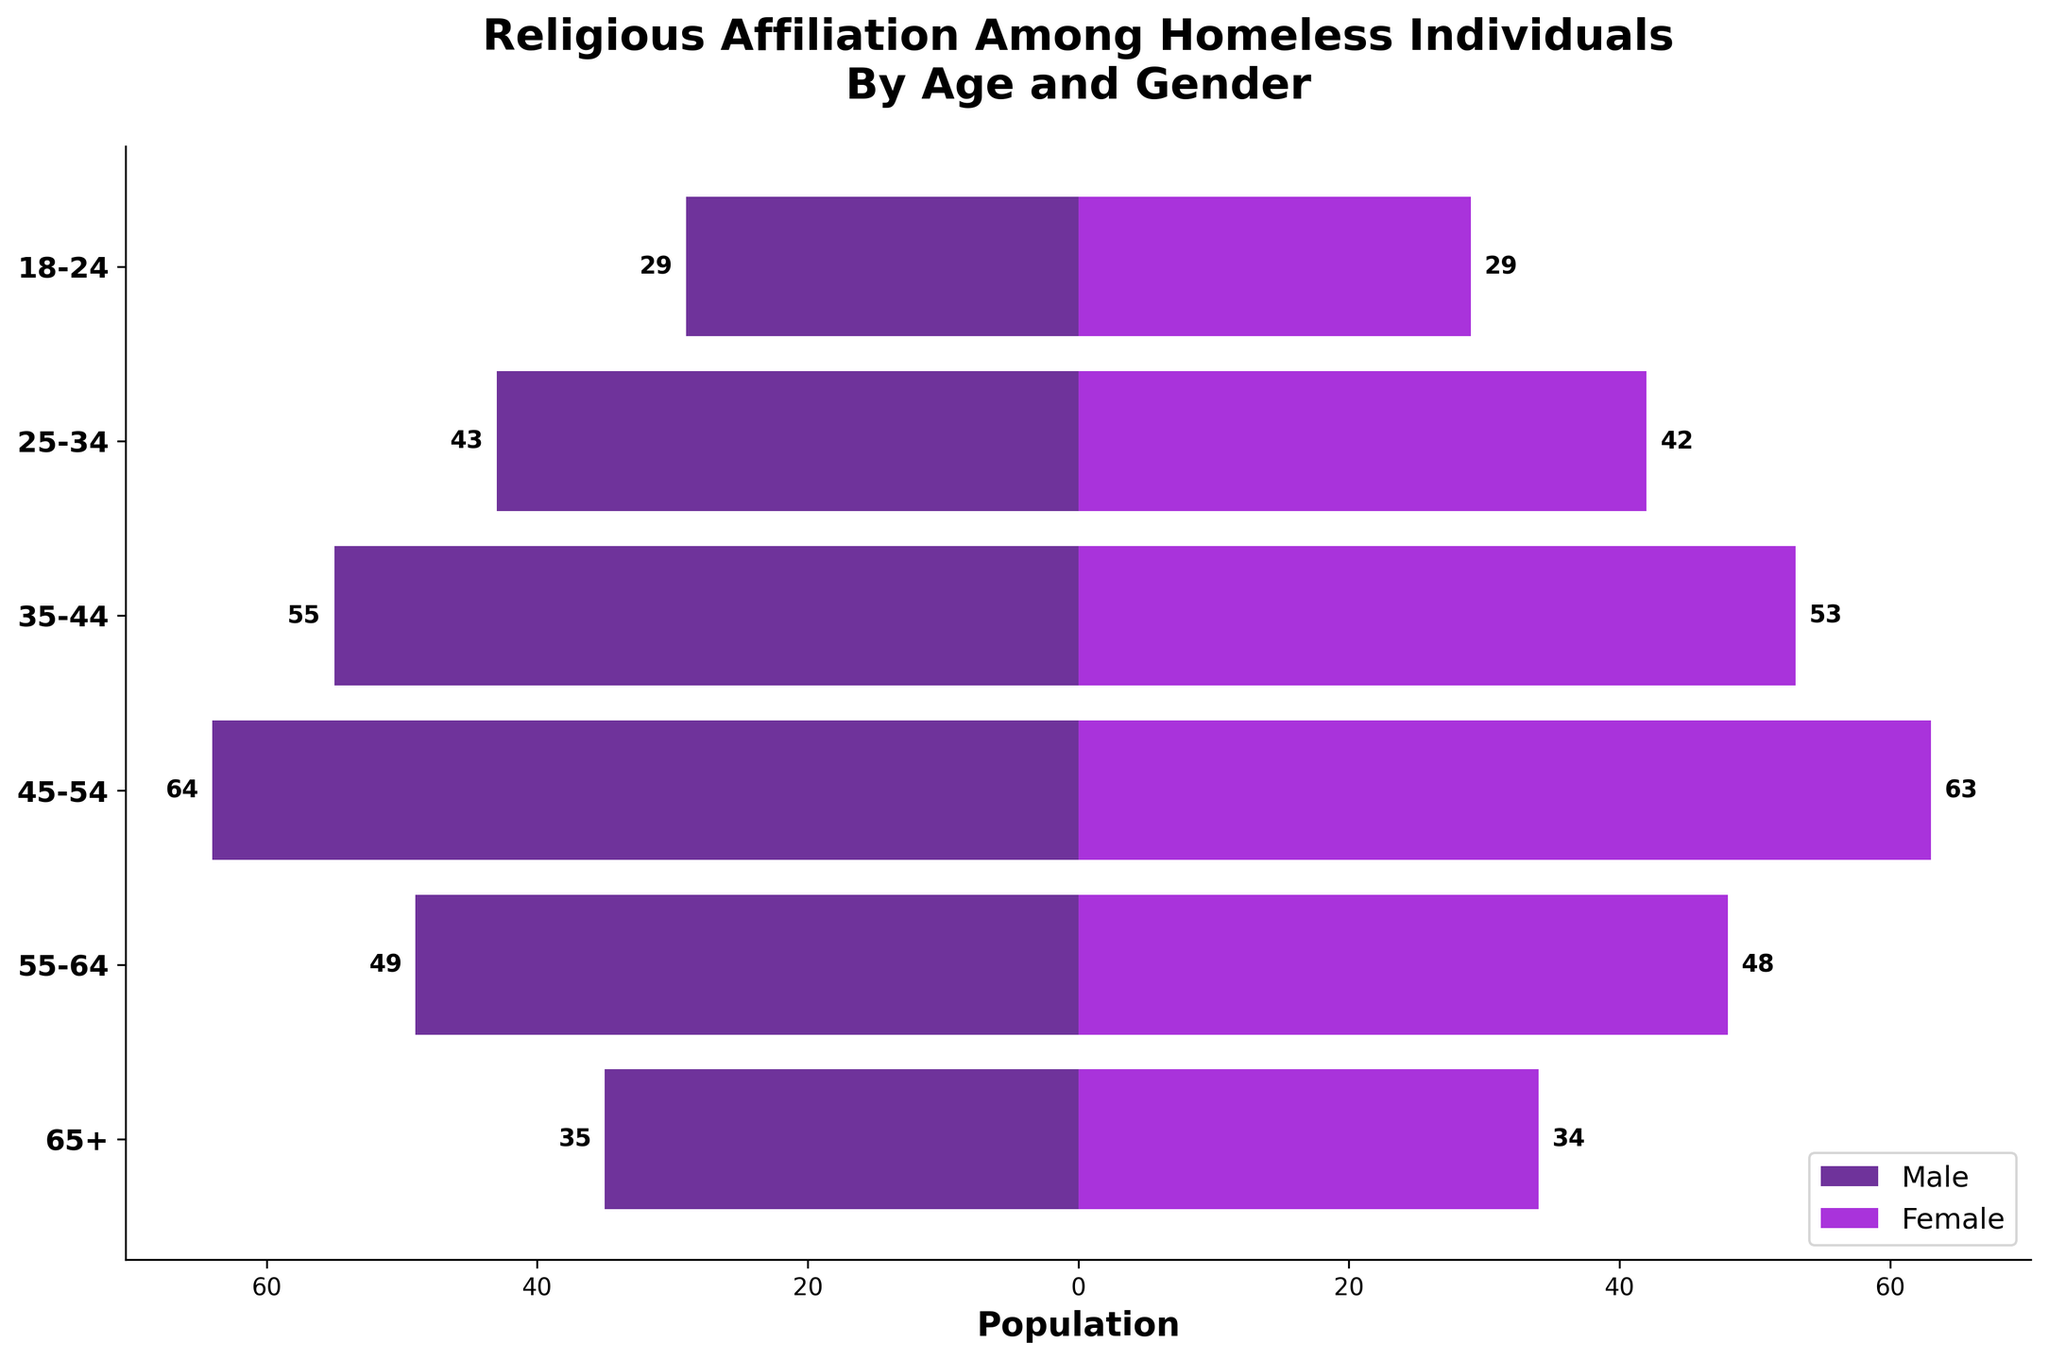What's the title of this figure? The title is usually placed at the top of the figure. By reading the text at the top, we can identify the title of the figure.
Answer: Religious Affiliation Among Homeless Individuals By Age and Gender What are the age groups listed on the y-axis? The y-axis labels the different age groups, which are displayed vertically. By reading these labels, we can determine the age groups.
Answer: 18-24, 25-34, 35-44, 45-54, 55-64, 65+ Which gender has the highest population in the 35-44 age group? By looking at the horizontal bars corresponding to the 35-44 age group, we can compare the lengths of the bars for males and females and identify the gender with the longer bar.
Answer: Female Is the population of male Christians always higher than female Christians in each age group? For each age group, compare the bars representing male Christians and female Christians to see if the male Christian population bar is longer in every case.
Answer: No What is the total number of atheist individuals in the 45-54 age group? Sum the population of male atheists and female atheists in the 45-54 age group by adding the values represented by their bars.
Answer: 34 Which religion has the least representation in the 55-64 age group for males? Compare the lengths of the bars for male Christians, Muslims, Atheists, and Others in this age group to identify the shortest bar, indicating the least representation.
Answer: Male Other How does the male population compare to the female population in the oldest age group (65+)? Look at the horizontal bars for both males and females in the 65+ age group and compare their lengths to see the difference in populations.
Answer: The male population is smaller than the female population What is the combined population for all religions in the 25-34 age group for females? Sum the populations of female Christians, Muslims, Atheists, and Others in the 25-34 age group by adding the values represented by their bars.
Answer: 42 